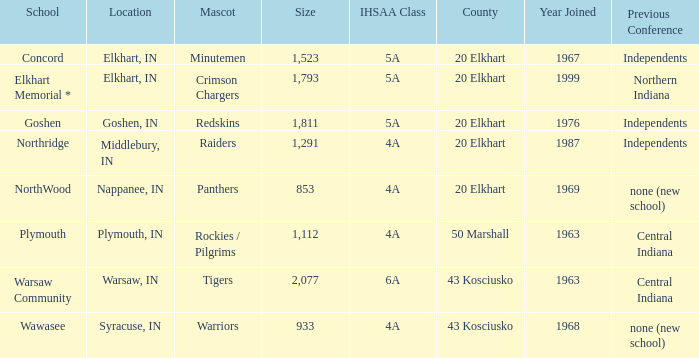What is the IHSAA class for the team located in Middlebury, IN? 4A. 